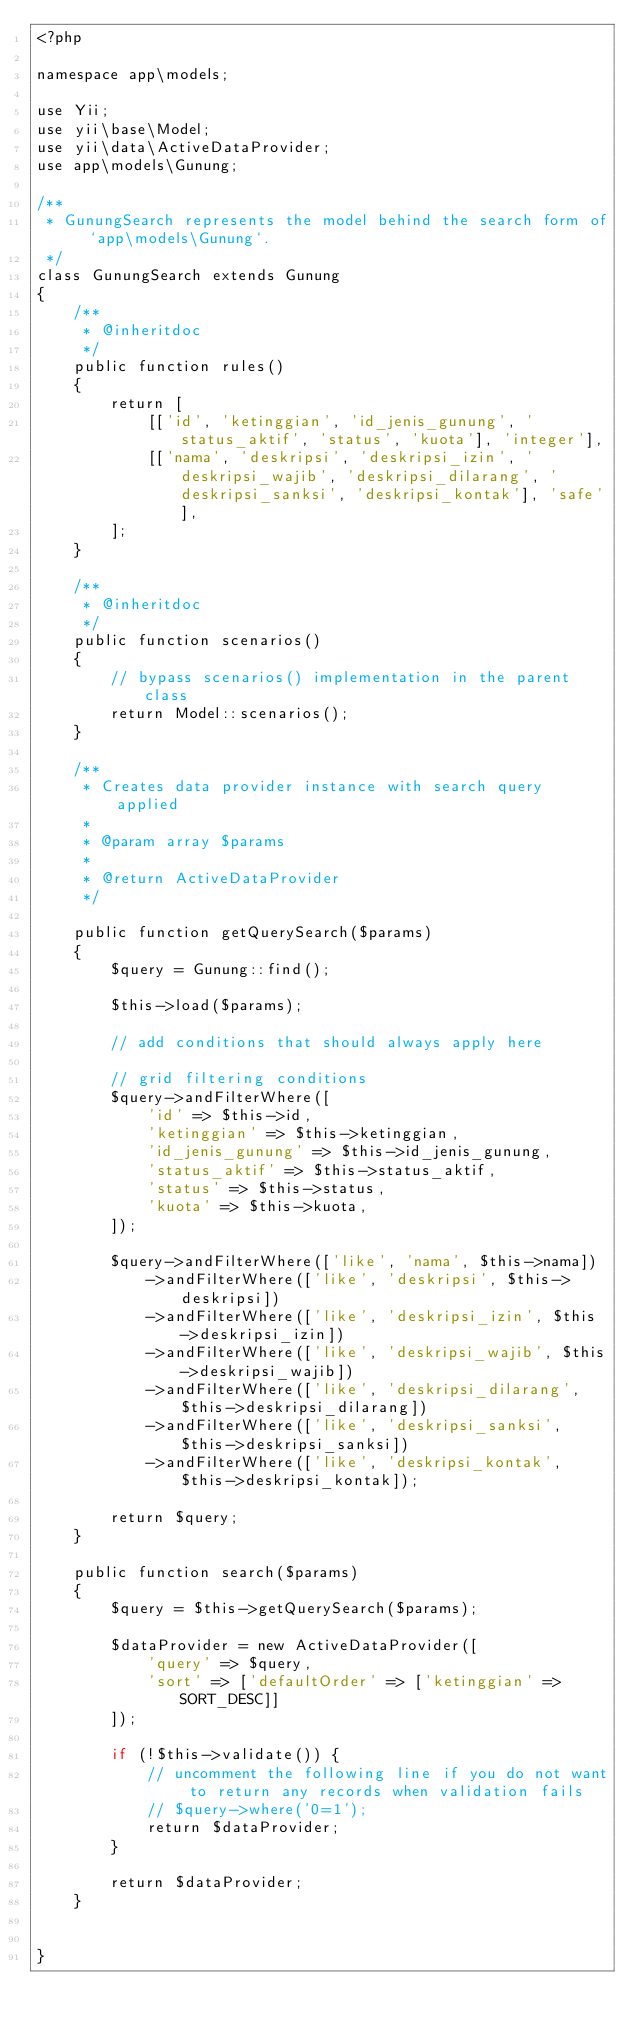Convert code to text. <code><loc_0><loc_0><loc_500><loc_500><_PHP_><?php

namespace app\models;

use Yii;
use yii\base\Model;
use yii\data\ActiveDataProvider;
use app\models\Gunung;

/**
 * GunungSearch represents the model behind the search form of `app\models\Gunung`.
 */
class GunungSearch extends Gunung
{
    /**
     * @inheritdoc
     */
    public function rules()
    {
        return [
            [['id', 'ketinggian', 'id_jenis_gunung', 'status_aktif', 'status', 'kuota'], 'integer'],
            [['nama', 'deskripsi', 'deskripsi_izin', 'deskripsi_wajib', 'deskripsi_dilarang', 'deskripsi_sanksi', 'deskripsi_kontak'], 'safe'],
        ];
    }

    /**
     * @inheritdoc
     */
    public function scenarios()
    {
        // bypass scenarios() implementation in the parent class
        return Model::scenarios();
    }

    /**
     * Creates data provider instance with search query applied
     *
     * @param array $params
     *
     * @return ActiveDataProvider
     */

    public function getQuerySearch($params)
    {
        $query = Gunung::find();

        $this->load($params);

        // add conditions that should always apply here

        // grid filtering conditions
        $query->andFilterWhere([
            'id' => $this->id,
            'ketinggian' => $this->ketinggian,
            'id_jenis_gunung' => $this->id_jenis_gunung,
            'status_aktif' => $this->status_aktif,
            'status' => $this->status,
            'kuota' => $this->kuota,
        ]);

        $query->andFilterWhere(['like', 'nama', $this->nama])
            ->andFilterWhere(['like', 'deskripsi', $this->deskripsi])
            ->andFilterWhere(['like', 'deskripsi_izin', $this->deskripsi_izin])
            ->andFilterWhere(['like', 'deskripsi_wajib', $this->deskripsi_wajib])
            ->andFilterWhere(['like', 'deskripsi_dilarang', $this->deskripsi_dilarang])
            ->andFilterWhere(['like', 'deskripsi_sanksi', $this->deskripsi_sanksi])
            ->andFilterWhere(['like', 'deskripsi_kontak', $this->deskripsi_kontak]);

        return $query;
    }
    
    public function search($params)
    {
        $query = $this->getQuerySearch($params);

        $dataProvider = new ActiveDataProvider([
            'query' => $query,
            'sort' => ['defaultOrder' => ['ketinggian' => SORT_DESC]]
        ]);

        if (!$this->validate()) {
            // uncomment the following line if you do not want to return any records when validation fails
            // $query->where('0=1');
            return $dataProvider;
        }

        return $dataProvider;
    }


}
</code> 